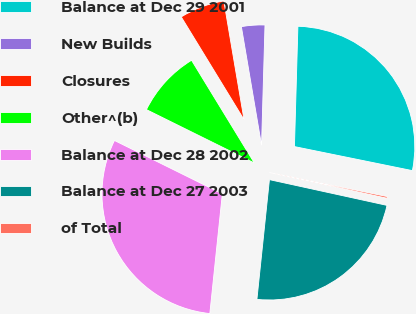Convert chart to OTSL. <chart><loc_0><loc_0><loc_500><loc_500><pie_chart><fcel>Balance at Dec 29 2001<fcel>New Builds<fcel>Closures<fcel>Other^(b)<fcel>Balance at Dec 28 2002<fcel>Balance at Dec 27 2003<fcel>of Total<nl><fcel>27.75%<fcel>3.14%<fcel>6.05%<fcel>8.96%<fcel>30.66%<fcel>23.23%<fcel>0.23%<nl></chart> 